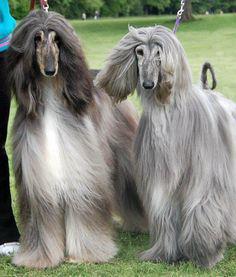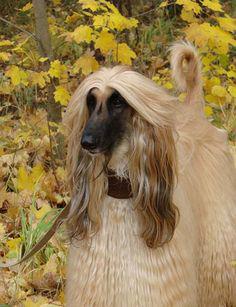The first image is the image on the left, the second image is the image on the right. For the images shown, is this caption "There are no fewer than 3 dogs." true? Answer yes or no. Yes. The first image is the image on the left, the second image is the image on the right. Given the left and right images, does the statement "The right and left image contains the same number of dogs." hold true? Answer yes or no. No. 